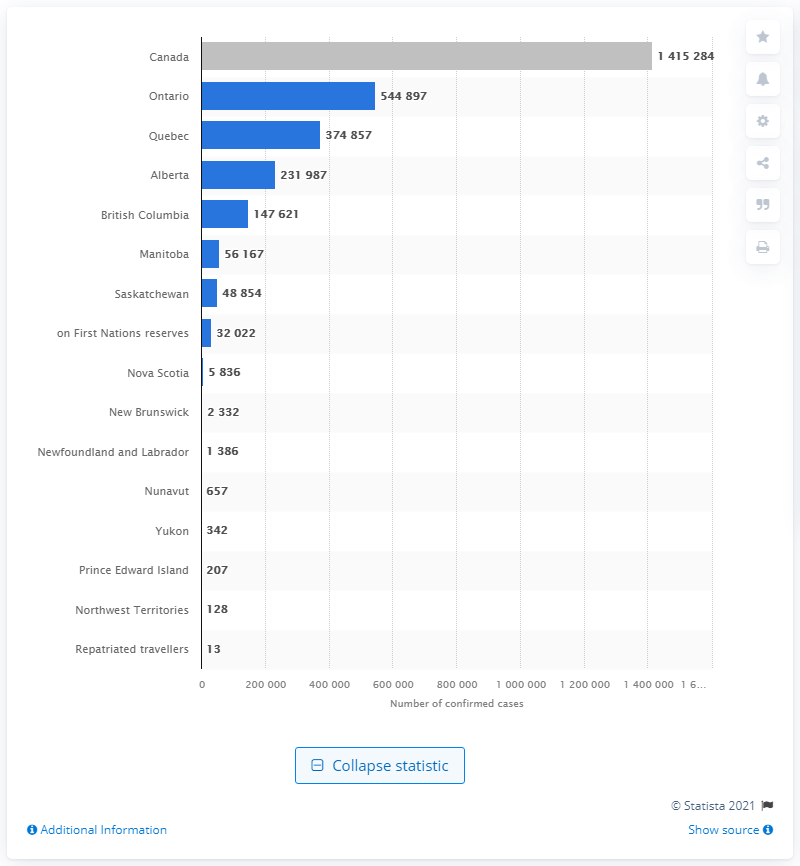Outline some significant characteristics in this image. As of June 30, 2021, there were 13 cases of coronavirus among repatriated travelers. Ontario has reported the highest number of confirmed cases of coronavirus. 